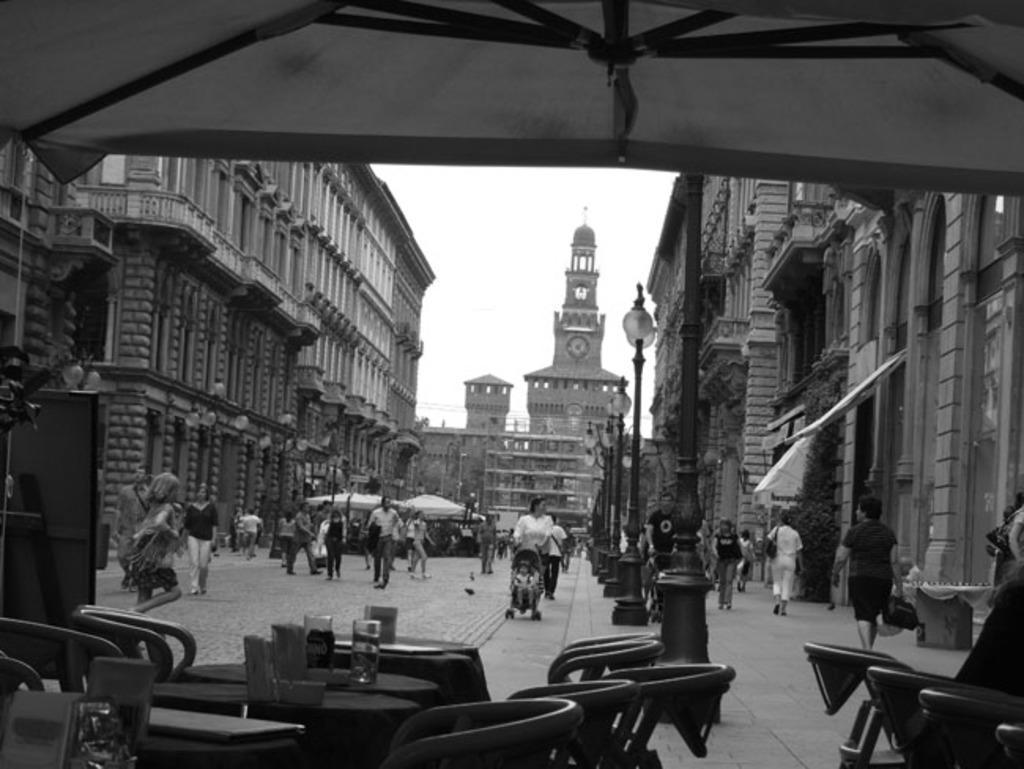Could you give a brief overview of what you see in this image? In this image we can see many people. There is a sky in the image. There are few umbrellas in the image. There are many tables and chairs in the image. There are few objects on the table. There is a tree in the image. There are many street lamps in the image. 